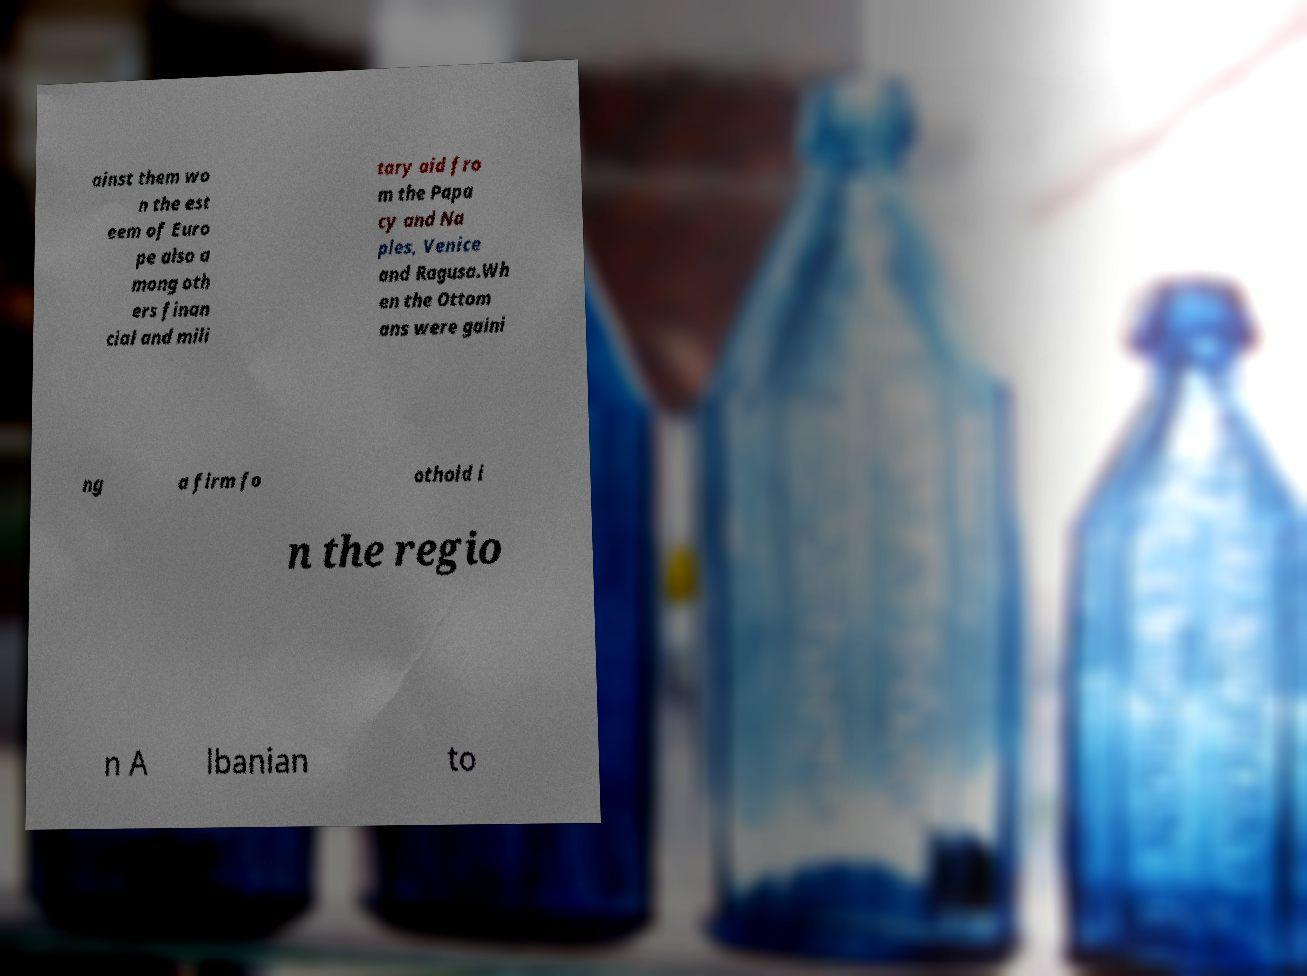What messages or text are displayed in this image? I need them in a readable, typed format. ainst them wo n the est eem of Euro pe also a mong oth ers finan cial and mili tary aid fro m the Papa cy and Na ples, Venice and Ragusa.Wh en the Ottom ans were gaini ng a firm fo othold i n the regio n A lbanian to 